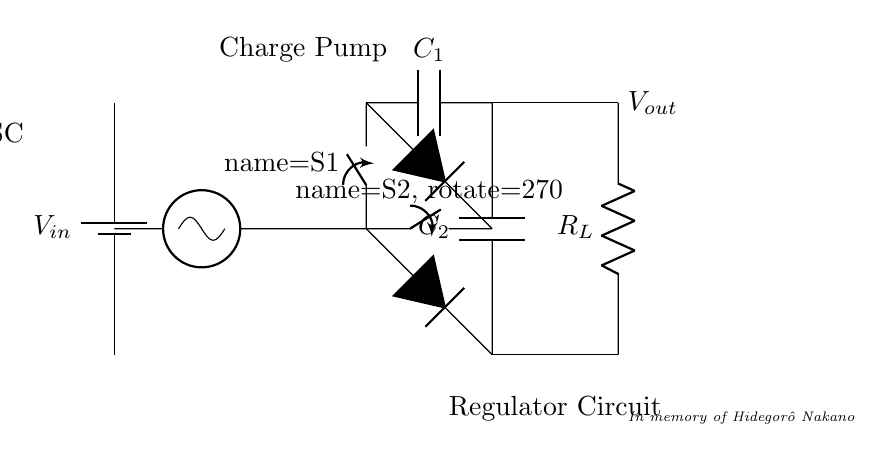What is the type of regulator depicted in the diagram? The circuit is a charge pump regulator as indicated by the charge pump label and the configuration of capacitors and switches.
Answer: Charge pump How many capacitors are in the circuit? The diagram shows two capacitors, labeled as C1 and C2, which provide charge storage and voltage boosting.
Answer: Two What is the role of the switches in this circuit? The switches (S1 and S2) control the charging and discharging of the capacitors, facilitating the operation of the charge pump to generate higher output voltage.
Answer: Control voltage What is the output voltage direction indicated by the diagram? The output voltage direction is to the right, as shown by the connection from the capacitors to the output node marked Vout.
Answer: Right What does the load resistor represent in this circuit? The load resistor, labeled as R_L, represents the component that consumes the output voltage provided by the charge pump regulator.
Answer: Load How do diodes function in this regulator circuit? The diodes (D1 and D2) prevent backflow of current, ensuring that charge from the capacitors is directed to the output without returning to the input side, aiding in voltage boosting.
Answer: Prevent backflow What is the significance of the oscillator in this charge pump circuit? The oscillator (OSC) generates the switching signal necessary for the operation of the charge pump, controlling when the switches open and close to manage the flow of charge between the capacitors.
Answer: Generate signal 